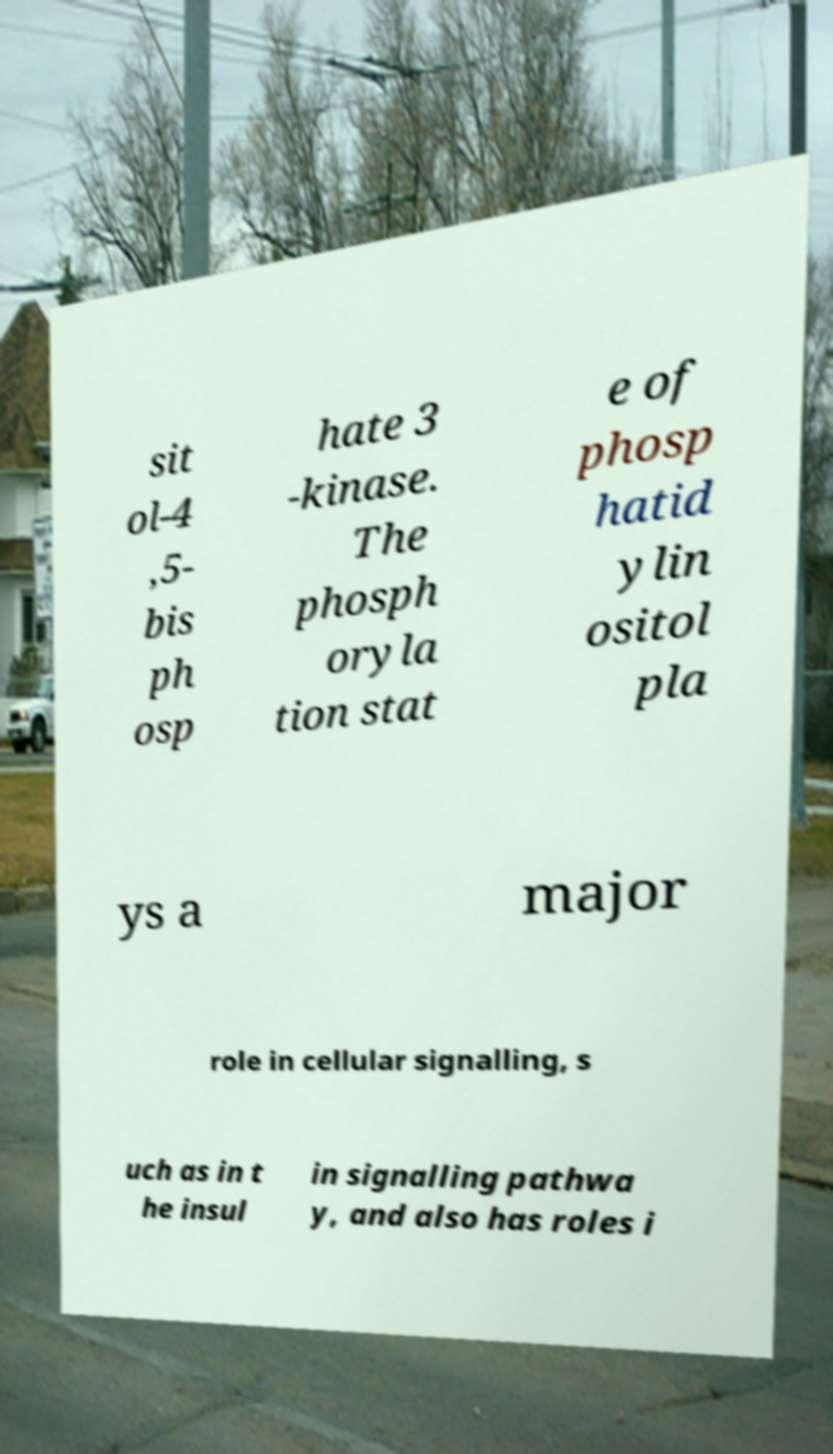For documentation purposes, I need the text within this image transcribed. Could you provide that? sit ol-4 ,5- bis ph osp hate 3 -kinase. The phosph oryla tion stat e of phosp hatid ylin ositol pla ys a major role in cellular signalling, s uch as in t he insul in signalling pathwa y, and also has roles i 